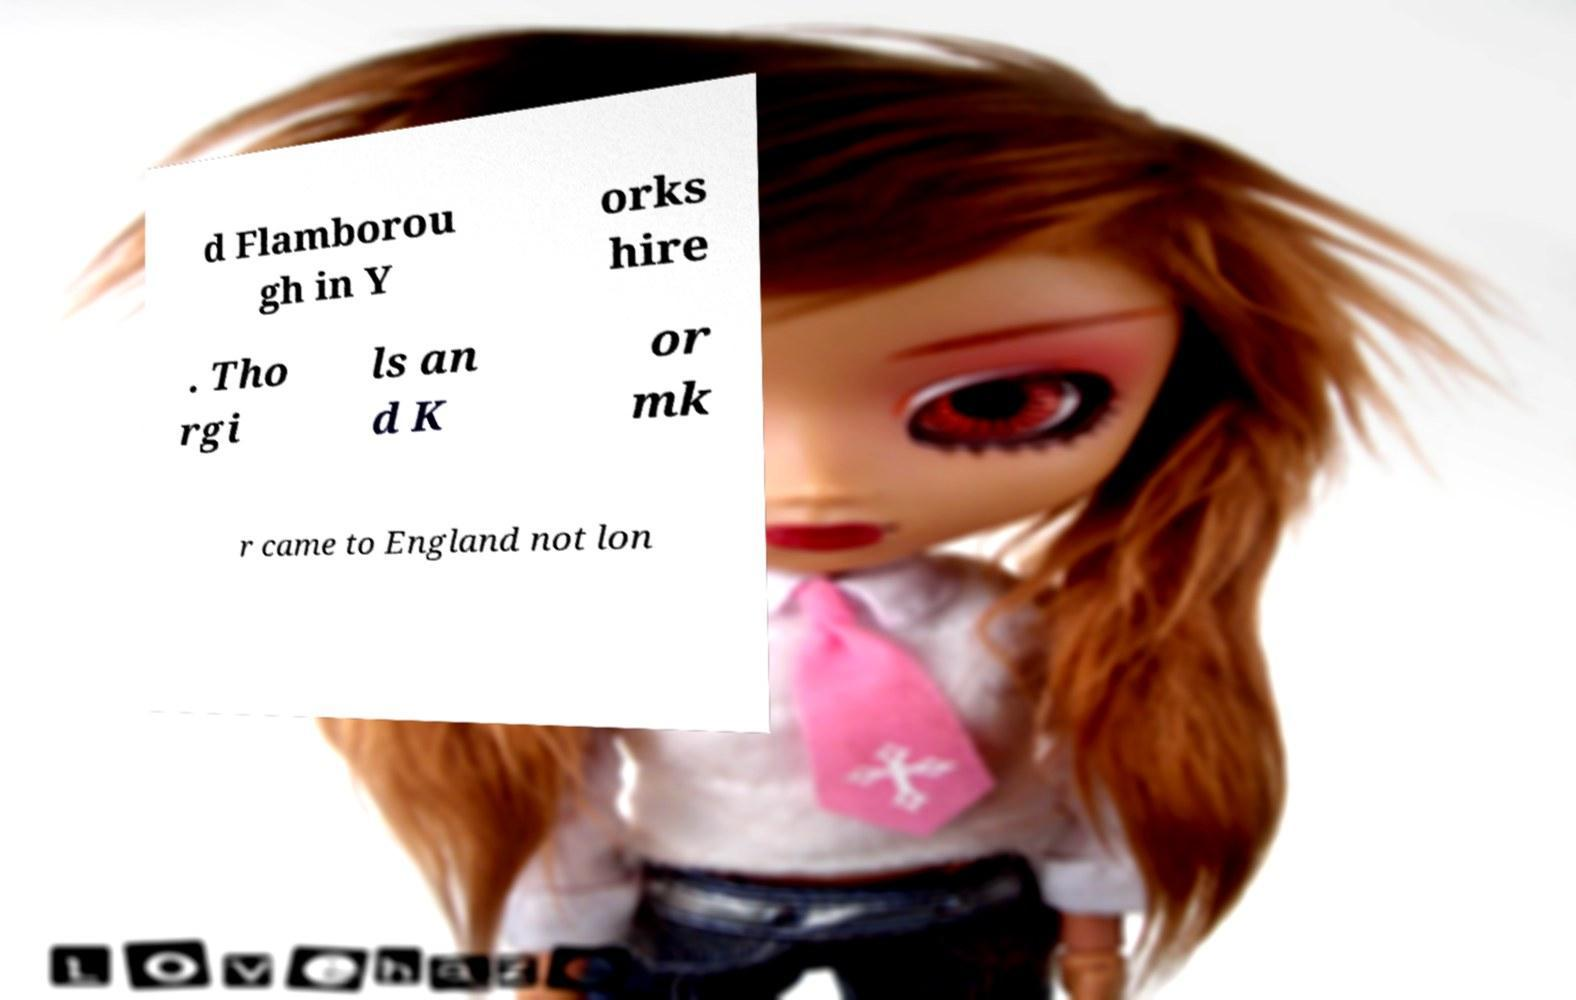Please read and relay the text visible in this image. What does it say? d Flamborou gh in Y orks hire . Tho rgi ls an d K or mk r came to England not lon 